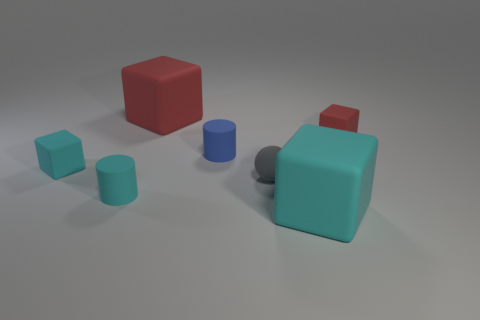There is a large red object; what number of small rubber cylinders are in front of it?
Give a very brief answer. 2. Are there an equal number of tiny gray objects that are left of the tiny cyan rubber cylinder and tiny cylinders behind the large cyan matte cube?
Your response must be concise. No. What size is the other cyan thing that is the same shape as the big cyan rubber object?
Make the answer very short. Small. There is a small thing on the right side of the gray matte ball; what shape is it?
Make the answer very short. Cube. Is the small cube left of the tiny red matte block made of the same material as the small blue thing that is behind the small gray rubber object?
Your response must be concise. Yes. What is the shape of the small gray thing?
Ensure brevity in your answer.  Sphere. Are there the same number of blue matte cylinders that are on the right side of the tiny cyan cube and tiny gray things?
Offer a very short reply. Yes. Are there any small brown cylinders made of the same material as the tiny gray ball?
Offer a very short reply. No. Do the big matte thing that is behind the tiny red object and the large thing in front of the small cyan rubber block have the same shape?
Your answer should be very brief. Yes. Are there any big purple metal objects?
Your answer should be very brief. No. 